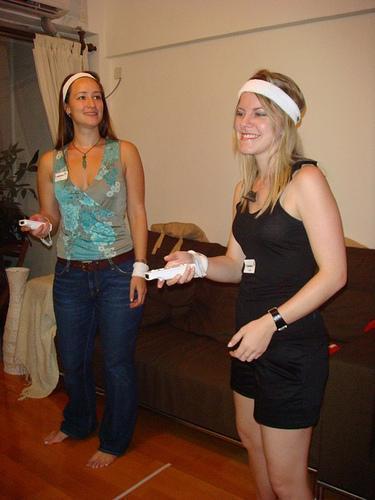How many people can be seen?
Give a very brief answer. 2. How many couches are in the photo?
Give a very brief answer. 1. How many birds are in the photo?
Give a very brief answer. 0. 